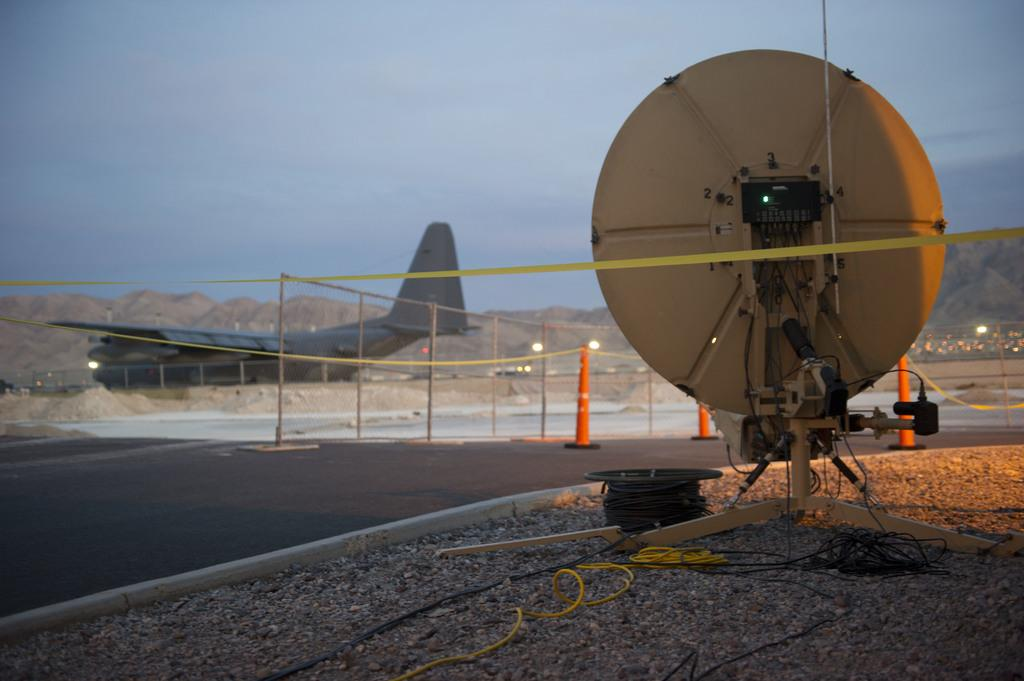What is the main subject of the image? The main subject of the image is an aeroplane. What color is the aeroplane? The aeroplane is grey in color. What else can be seen in the image besides the aeroplane? There is a road in the image. What is visible at the top of the image? The sky is visible at the top of the image. What type of tin can be seen in the image? There is no tin present in the image. What hobbies are the people in the image engaged in? The image does not show any people, so their hobbies cannot be determined. 